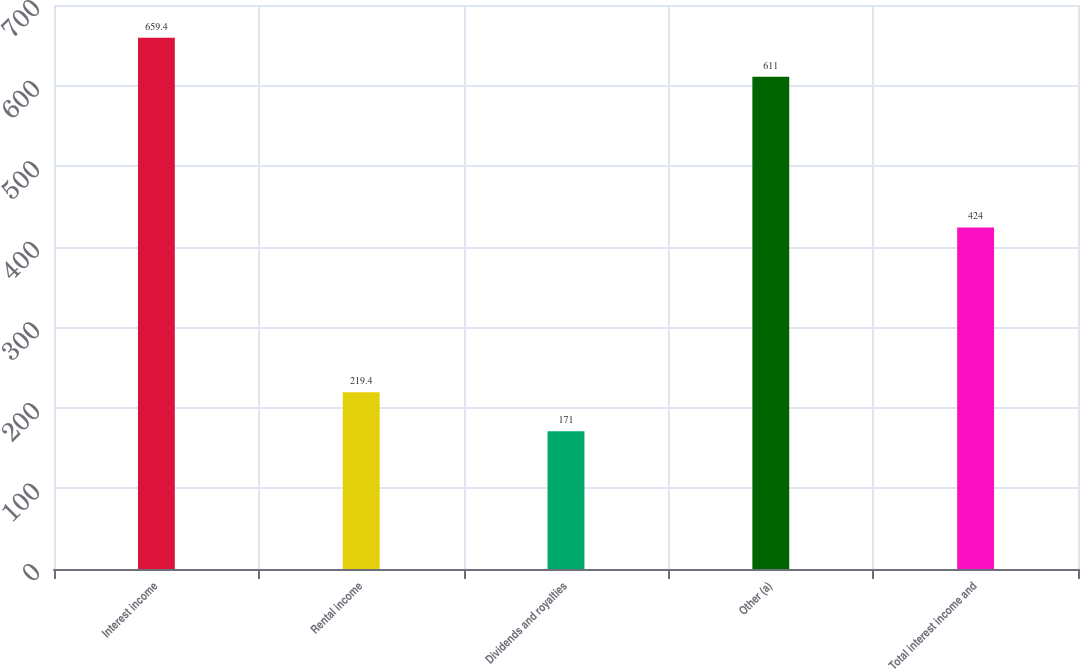Convert chart. <chart><loc_0><loc_0><loc_500><loc_500><bar_chart><fcel>Interest income<fcel>Rental income<fcel>Dividends and royalties<fcel>Other (a)<fcel>Total interest income and<nl><fcel>659.4<fcel>219.4<fcel>171<fcel>611<fcel>424<nl></chart> 